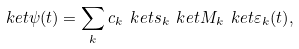Convert formula to latex. <formula><loc_0><loc_0><loc_500><loc_500>\ k e t { \psi ( t ) } = \sum _ { k } c _ { k } \ k e t { s _ { k } } \ k e t { M _ { k } } \ k e t { \varepsilon _ { k } ( t ) } ,</formula> 